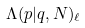<formula> <loc_0><loc_0><loc_500><loc_500>\Lambda ( p | q , N ) _ { \ell }</formula> 